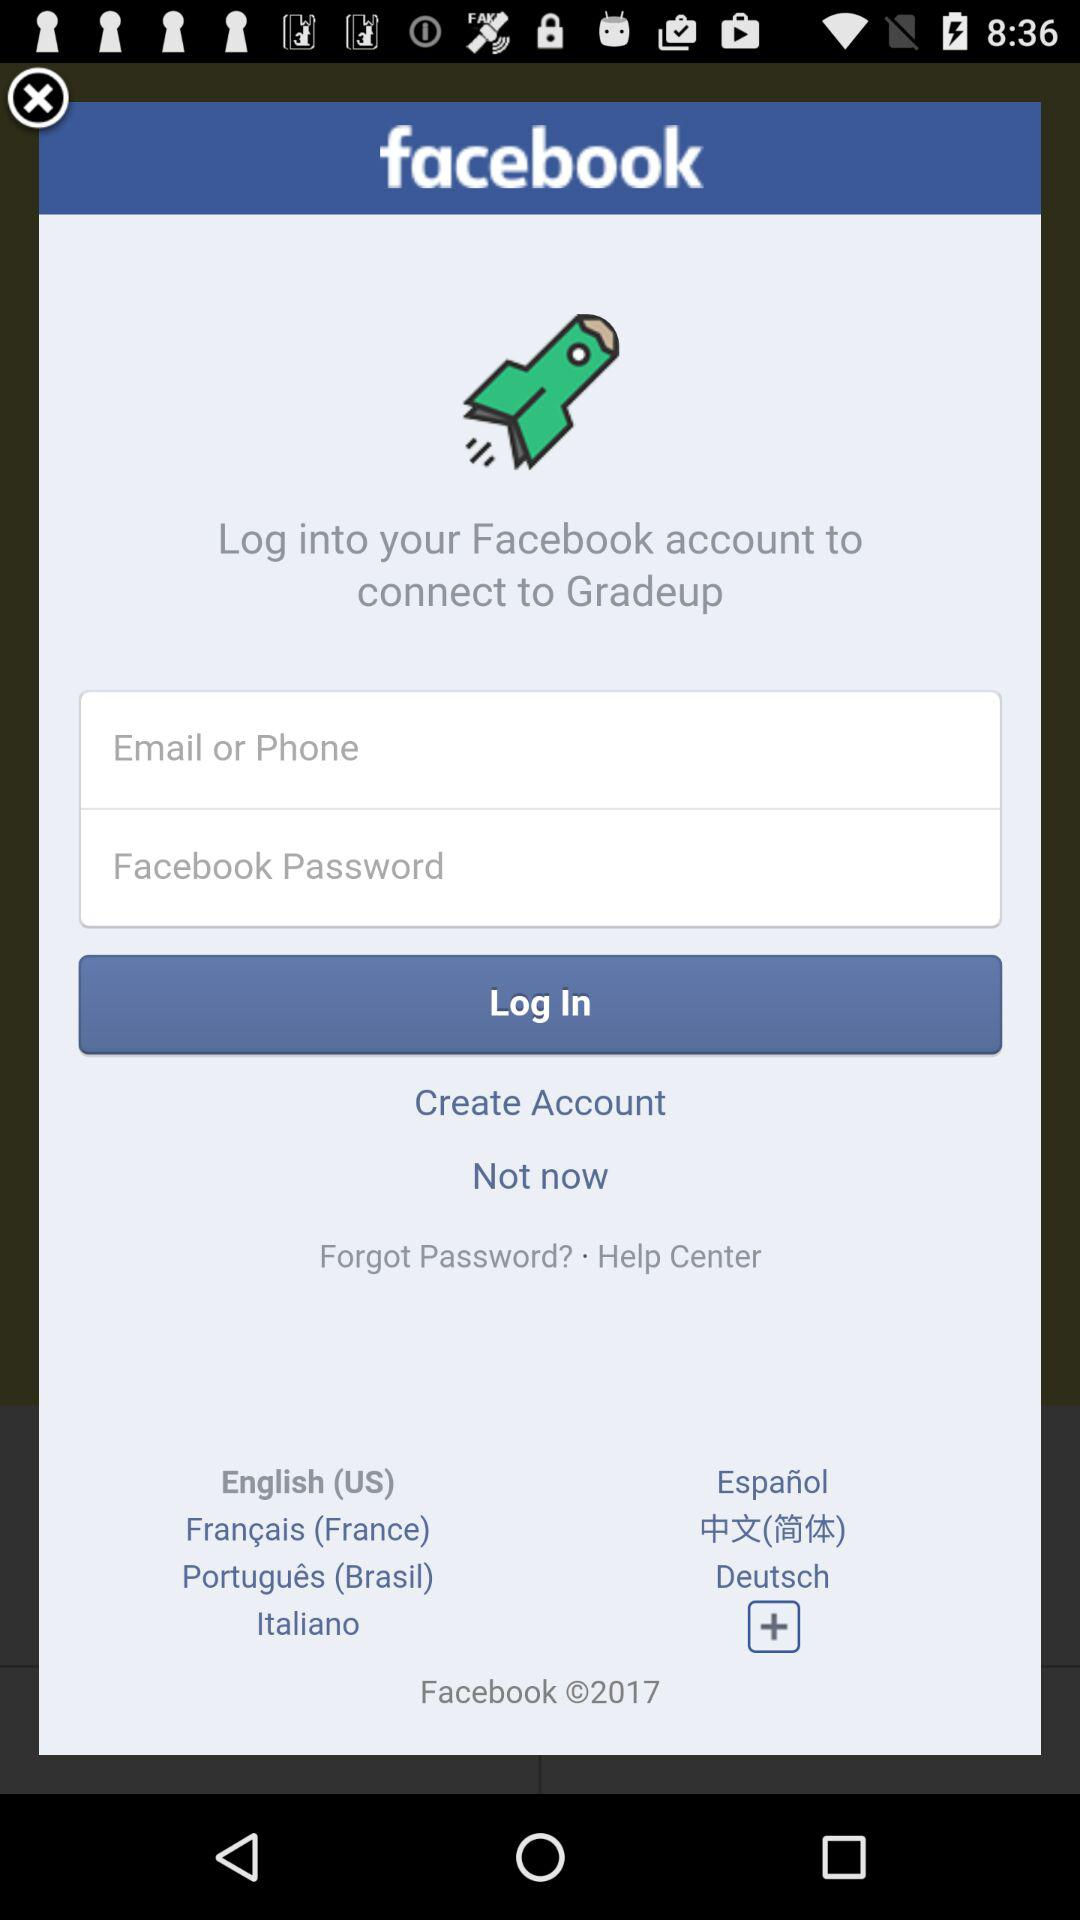Through what application can be login with? You can login with Facebook. 